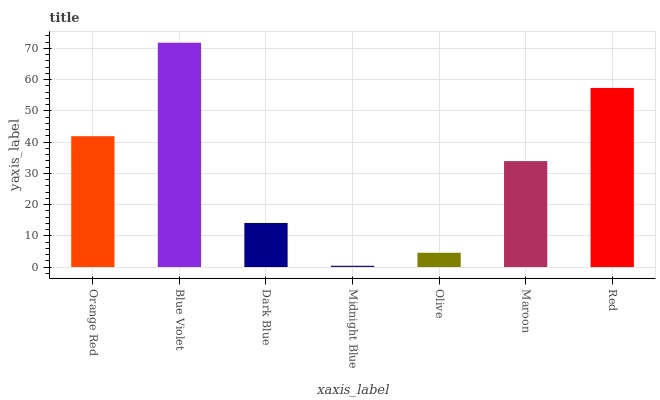Is Midnight Blue the minimum?
Answer yes or no. Yes. Is Blue Violet the maximum?
Answer yes or no. Yes. Is Dark Blue the minimum?
Answer yes or no. No. Is Dark Blue the maximum?
Answer yes or no. No. Is Blue Violet greater than Dark Blue?
Answer yes or no. Yes. Is Dark Blue less than Blue Violet?
Answer yes or no. Yes. Is Dark Blue greater than Blue Violet?
Answer yes or no. No. Is Blue Violet less than Dark Blue?
Answer yes or no. No. Is Maroon the high median?
Answer yes or no. Yes. Is Maroon the low median?
Answer yes or no. Yes. Is Orange Red the high median?
Answer yes or no. No. Is Blue Violet the low median?
Answer yes or no. No. 